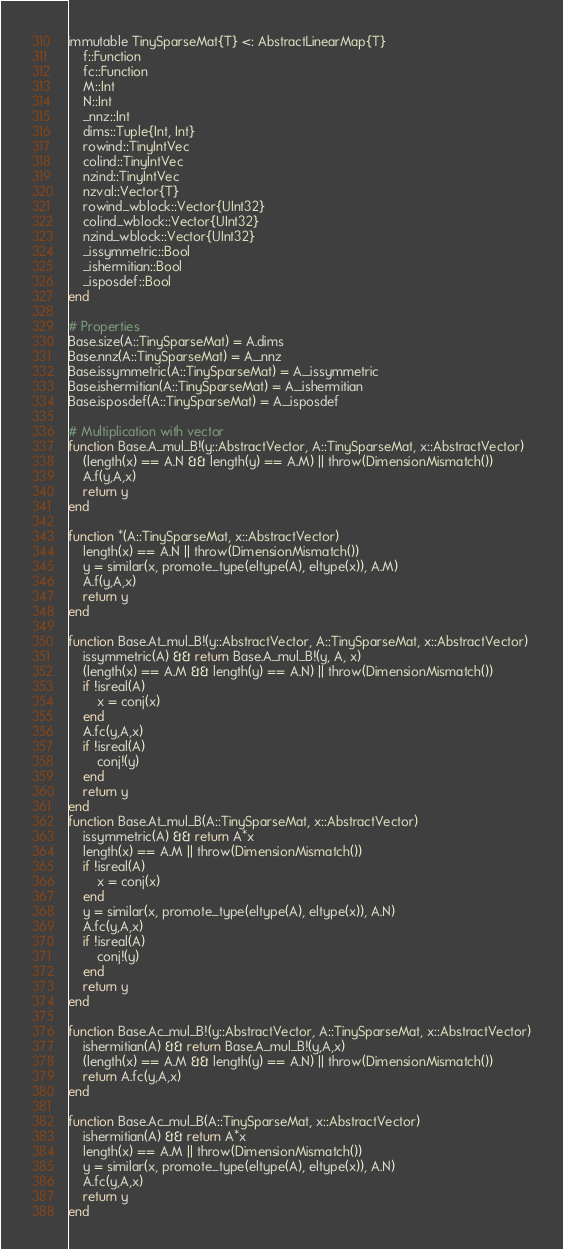Convert code to text. <code><loc_0><loc_0><loc_500><loc_500><_Julia_>immutable TinySparseMat{T} <: AbstractLinearMap{T}
    f::Function
    fc::Function
    M::Int
    N::Int
    _nnz::Int
    dims::Tuple{Int, Int}
    rowind::TinyIntVec
    colind::TinyIntVec
    nzind::TinyIntVec
    nzval::Vector{T}
    rowind_wblock::Vector{UInt32}
    colind_wblock::Vector{UInt32}
    nzind_wblock::Vector{UInt32}
    _issymmetric::Bool
    _ishermitian::Bool
    _isposdef::Bool
end

# Properties
Base.size(A::TinySparseMat) = A.dims
Base.nnz(A::TinySparseMat) = A._nnz
Base.issymmetric(A::TinySparseMat) = A._issymmetric
Base.ishermitian(A::TinySparseMat) = A._ishermitian
Base.isposdef(A::TinySparseMat) = A._isposdef

# Multiplication with vector
function Base.A_mul_B!(y::AbstractVector, A::TinySparseMat, x::AbstractVector)
    (length(x) == A.N && length(y) == A.M) || throw(DimensionMismatch())
    A.f(y,A,x)
    return y
end

function *(A::TinySparseMat, x::AbstractVector)
    length(x) == A.N || throw(DimensionMismatch())
    y = similar(x, promote_type(eltype(A), eltype(x)), A.M)
    A.f(y,A,x)
    return y
end

function Base.At_mul_B!(y::AbstractVector, A::TinySparseMat, x::AbstractVector)
    issymmetric(A) && return Base.A_mul_B!(y, A, x)
    (length(x) == A.M && length(y) == A.N) || throw(DimensionMismatch())
    if !isreal(A)
        x = conj(x)
    end
    A.fc(y,A,x)
    if !isreal(A)
        conj!(y)
    end
    return y
end
function Base.At_mul_B(A::TinySparseMat, x::AbstractVector)
    issymmetric(A) && return A*x
    length(x) == A.M || throw(DimensionMismatch())
    if !isreal(A)
        x = conj(x)
    end
    y = similar(x, promote_type(eltype(A), eltype(x)), A.N)
    A.fc(y,A,x)
    if !isreal(A)
        conj!(y)
    end
    return y
end

function Base.Ac_mul_B!(y::AbstractVector, A::TinySparseMat, x::AbstractVector)
    ishermitian(A) && return Base.A_mul_B!(y,A,x)
    (length(x) == A.M && length(y) == A.N) || throw(DimensionMismatch())
    return A.fc(y,A,x)
end

function Base.Ac_mul_B(A::TinySparseMat, x::AbstractVector)
    ishermitian(A) && return A*x
    length(x) == A.M || throw(DimensionMismatch())
    y = similar(x, promote_type(eltype(A), eltype(x)), A.N)
    A.fc(y,A,x)
    return y
end</code> 